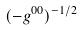<formula> <loc_0><loc_0><loc_500><loc_500>( - g ^ { 0 0 } ) ^ { - 1 / 2 }</formula> 